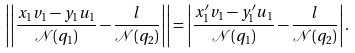<formula> <loc_0><loc_0><loc_500><loc_500>\left | \left | \frac { x _ { 1 } v _ { 1 } - y _ { 1 } u _ { 1 } } { \mathcal { N } ( q _ { 1 } ) } - \frac { l } { \mathcal { N } ( q _ { 2 } ) } \right | \right | = \left | \frac { x _ { 1 } ^ { \prime } v _ { 1 } - y _ { 1 } ^ { \prime } u _ { 1 } } { \mathcal { N } ( q _ { 1 } ) } - \frac { l } { \mathcal { N } ( q _ { 2 } ) } \right | .</formula> 